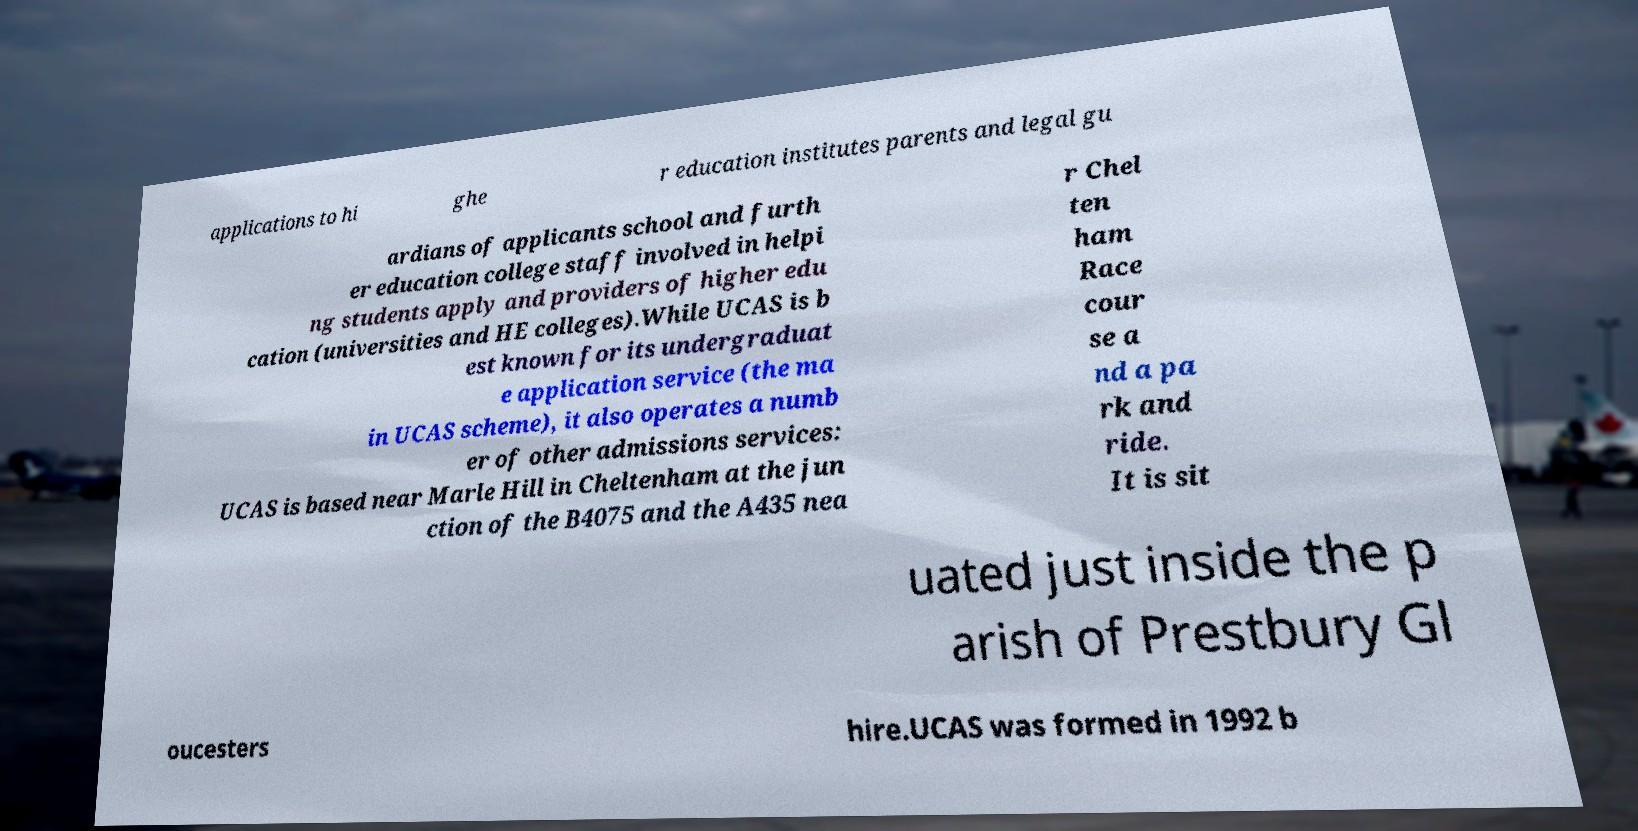For documentation purposes, I need the text within this image transcribed. Could you provide that? applications to hi ghe r education institutes parents and legal gu ardians of applicants school and furth er education college staff involved in helpi ng students apply and providers of higher edu cation (universities and HE colleges).While UCAS is b est known for its undergraduat e application service (the ma in UCAS scheme), it also operates a numb er of other admissions services: UCAS is based near Marle Hill in Cheltenham at the jun ction of the B4075 and the A435 nea r Chel ten ham Race cour se a nd a pa rk and ride. It is sit uated just inside the p arish of Prestbury Gl oucesters hire.UCAS was formed in 1992 b 